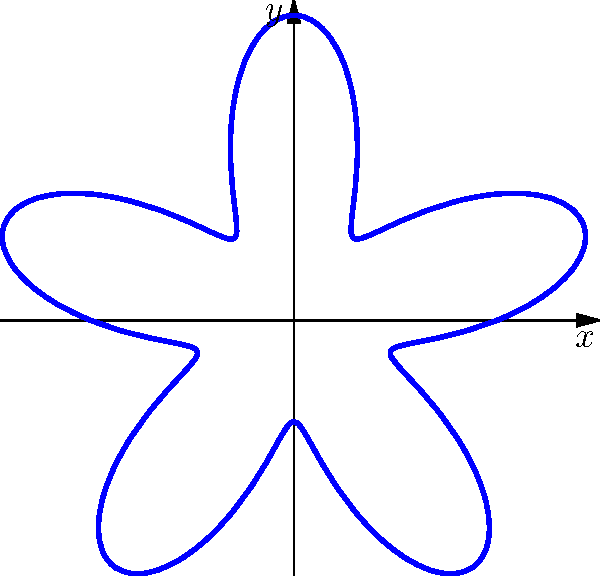For a meditative art installation, you want to create a mandala-like pattern using polar coordinates. The equation $r = 2 + \sin(5\theta)$ is proposed. How many petals or lobes will this pattern have, and what is the significance of the number 5 in the equation? To determine the number of petals or lobes in the mandala-like pattern, we need to analyze the given polar equation:

1. The equation is $r = 2 + \sin(5\theta)$

2. In polar equations, the number of petals or lobes is determined by the coefficient of $\theta$ inside the trigonometric function.

3. In this case, we have $\sin(5\theta)$, where 5 is the coefficient of $\theta$.

4. The number of petals or lobes is equal to this coefficient when it's an odd number.

5. Since 5 is an odd number, the pattern will have 5 petals or lobes.

6. The significance of the number 5 in the equation:
   a) It determines the number of petals or lobes in the pattern.
   b) It controls the frequency of the sinusoidal variation as $\theta$ increases.
   c) It creates a five-fold rotational symmetry in the pattern.

7. The constant term 2 in the equation shifts the entire pattern outward from the origin, ensuring that the curve never touches the center point.

This design creates a balanced, symmetrical pattern with five distinct lobes, making it suitable for a meditative art installation that emphasizes harmony and repetition.
Answer: 5 petals; determines symmetry and lobe count 